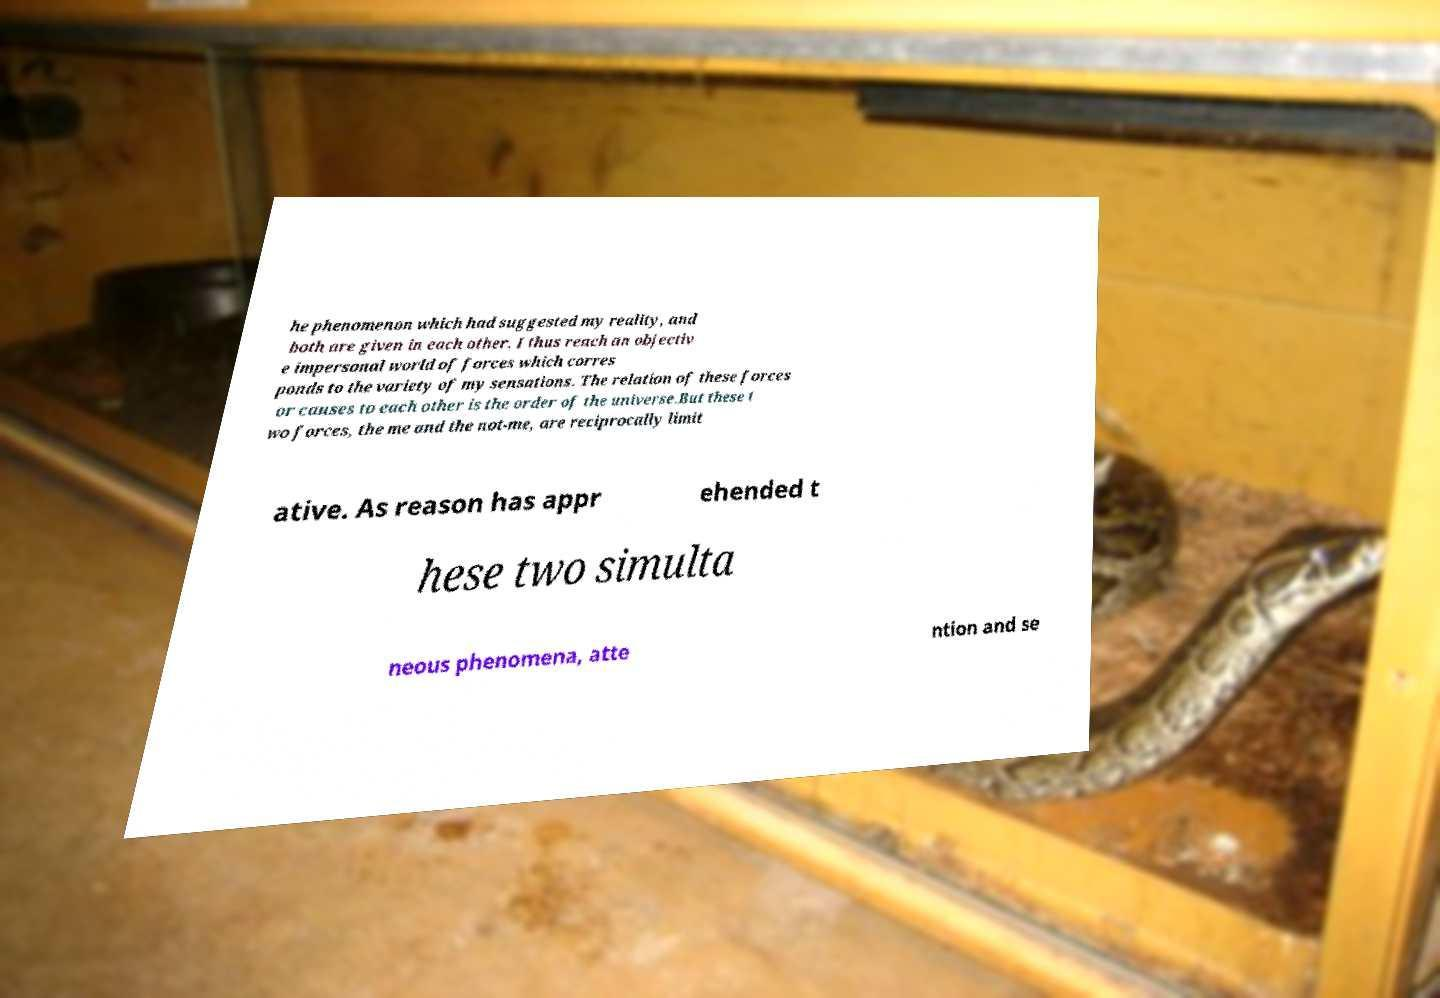Can you accurately transcribe the text from the provided image for me? he phenomenon which had suggested my reality, and both are given in each other. I thus reach an objectiv e impersonal world of forces which corres ponds to the variety of my sensations. The relation of these forces or causes to each other is the order of the universe.But these t wo forces, the me and the not-me, are reciprocally limit ative. As reason has appr ehended t hese two simulta neous phenomena, atte ntion and se 